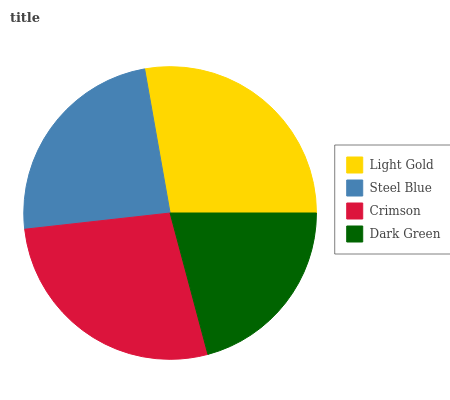Is Dark Green the minimum?
Answer yes or no. Yes. Is Light Gold the maximum?
Answer yes or no. Yes. Is Steel Blue the minimum?
Answer yes or no. No. Is Steel Blue the maximum?
Answer yes or no. No. Is Light Gold greater than Steel Blue?
Answer yes or no. Yes. Is Steel Blue less than Light Gold?
Answer yes or no. Yes. Is Steel Blue greater than Light Gold?
Answer yes or no. No. Is Light Gold less than Steel Blue?
Answer yes or no. No. Is Crimson the high median?
Answer yes or no. Yes. Is Steel Blue the low median?
Answer yes or no. Yes. Is Light Gold the high median?
Answer yes or no. No. Is Light Gold the low median?
Answer yes or no. No. 